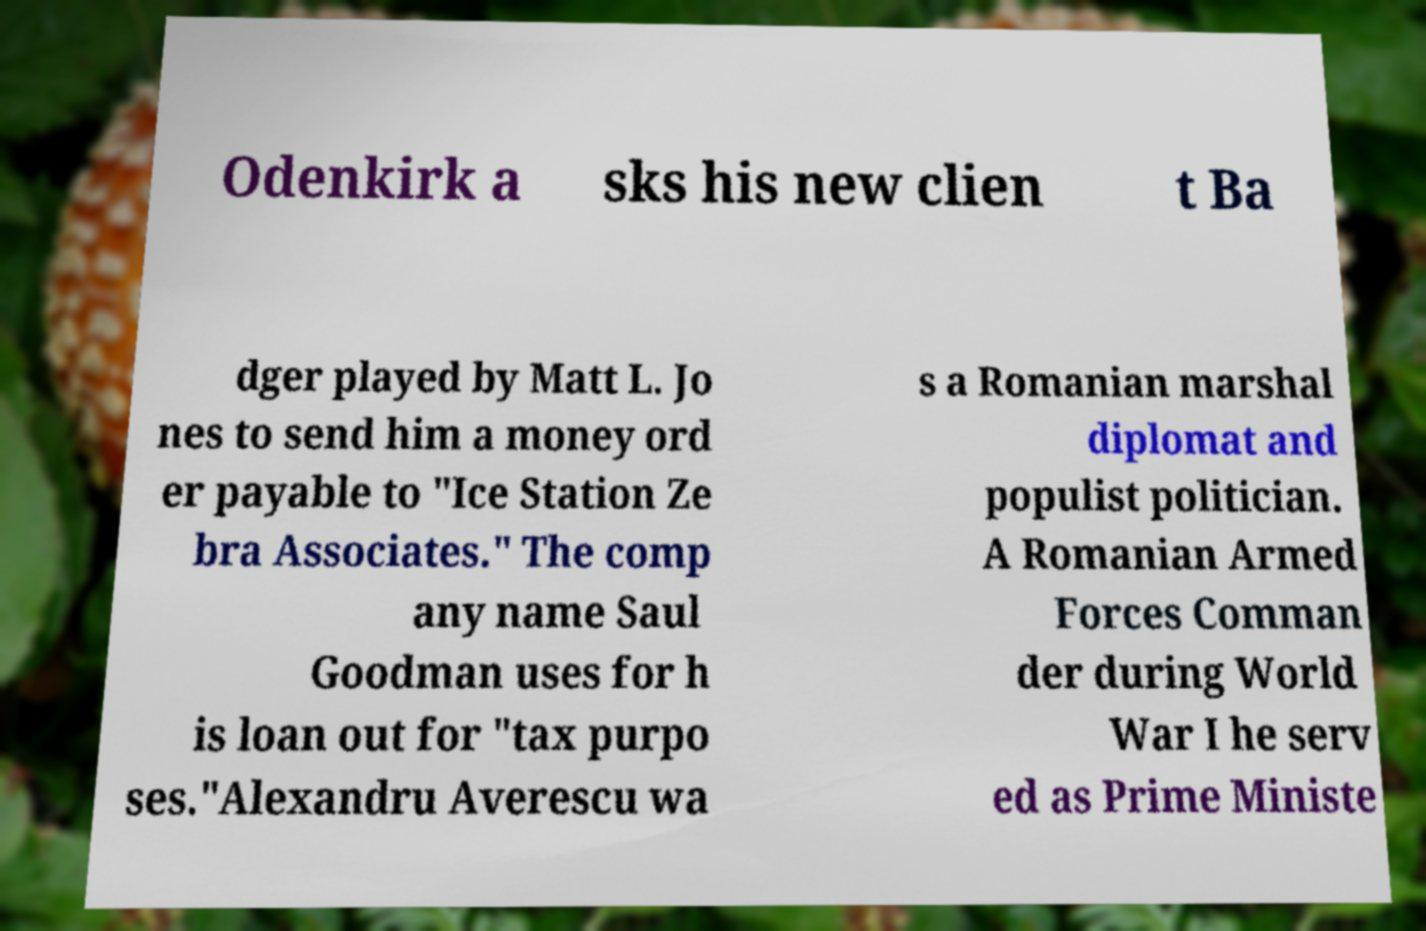What messages or text are displayed in this image? I need them in a readable, typed format. Odenkirk a sks his new clien t Ba dger played by Matt L. Jo nes to send him a money ord er payable to "Ice Station Ze bra Associates." The comp any name Saul Goodman uses for h is loan out for "tax purpo ses."Alexandru Averescu wa s a Romanian marshal diplomat and populist politician. A Romanian Armed Forces Comman der during World War I he serv ed as Prime Ministe 